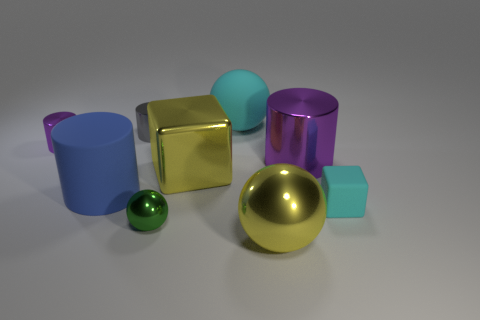Add 1 small brown objects. How many objects exist? 10 Subtract all spheres. How many objects are left? 6 Add 6 large matte spheres. How many large matte spheres exist? 7 Subtract 0 brown spheres. How many objects are left? 9 Subtract all rubber cubes. Subtract all shiny objects. How many objects are left? 2 Add 3 tiny green objects. How many tiny green objects are left? 4 